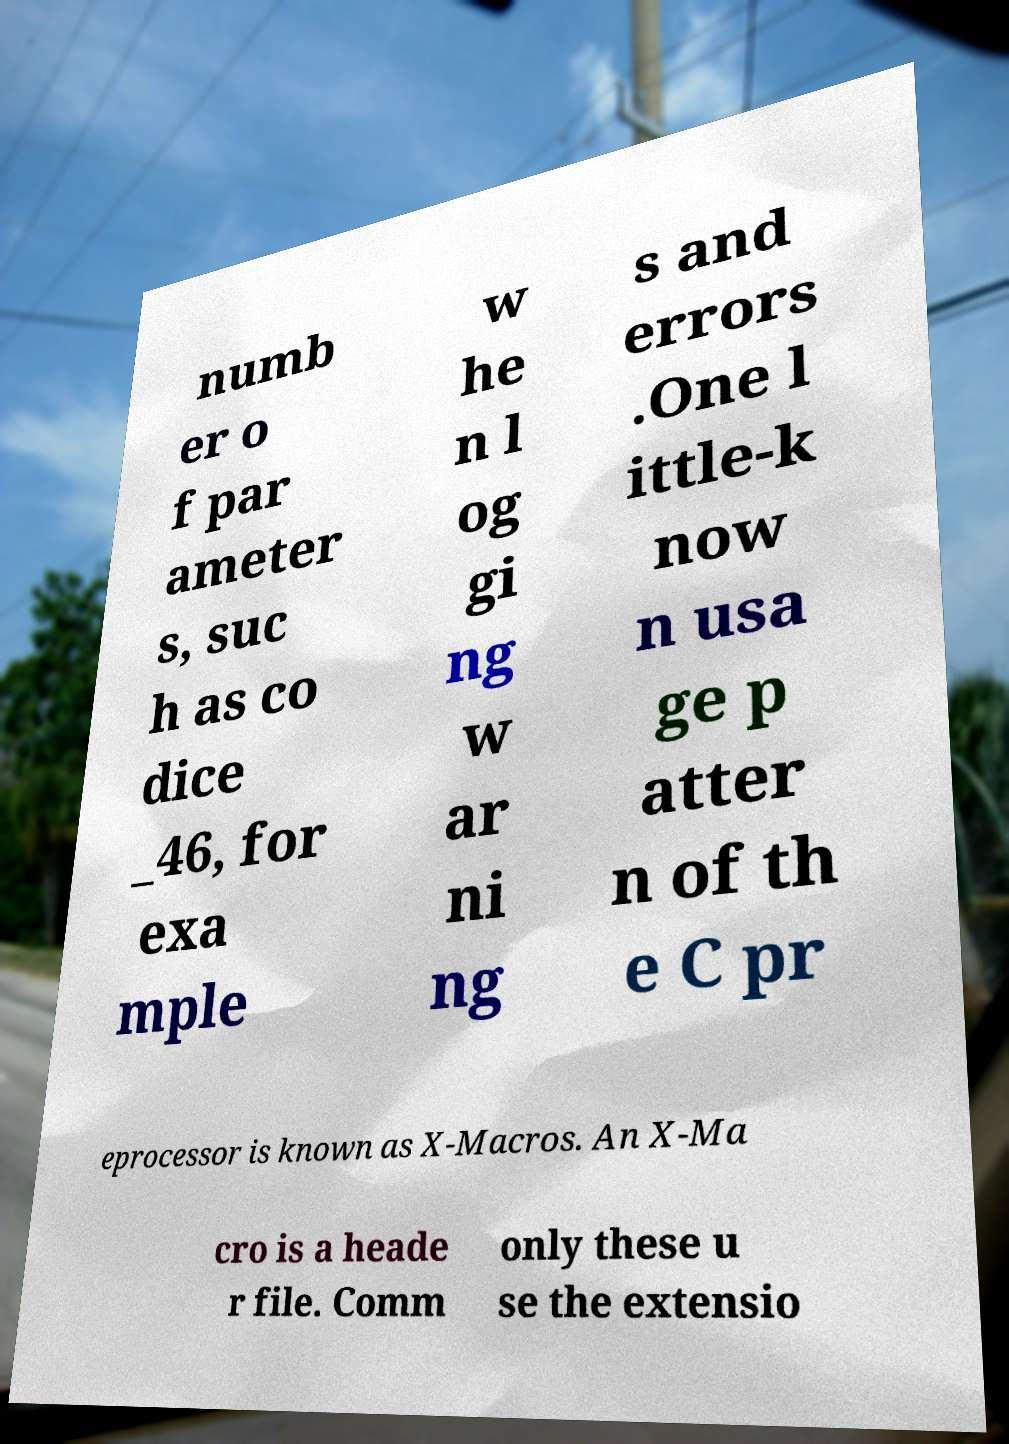Can you accurately transcribe the text from the provided image for me? numb er o f par ameter s, suc h as co dice _46, for exa mple w he n l og gi ng w ar ni ng s and errors .One l ittle-k now n usa ge p atter n of th e C pr eprocessor is known as X-Macros. An X-Ma cro is a heade r file. Comm only these u se the extensio 